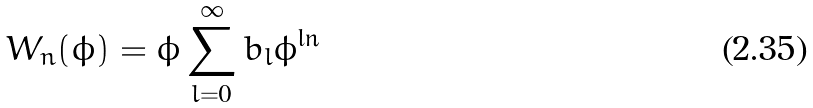<formula> <loc_0><loc_0><loc_500><loc_500>W _ { n } ( \phi ) = \phi \sum _ { l = 0 } ^ { \infty } b _ { l } \phi ^ { \ln }</formula> 